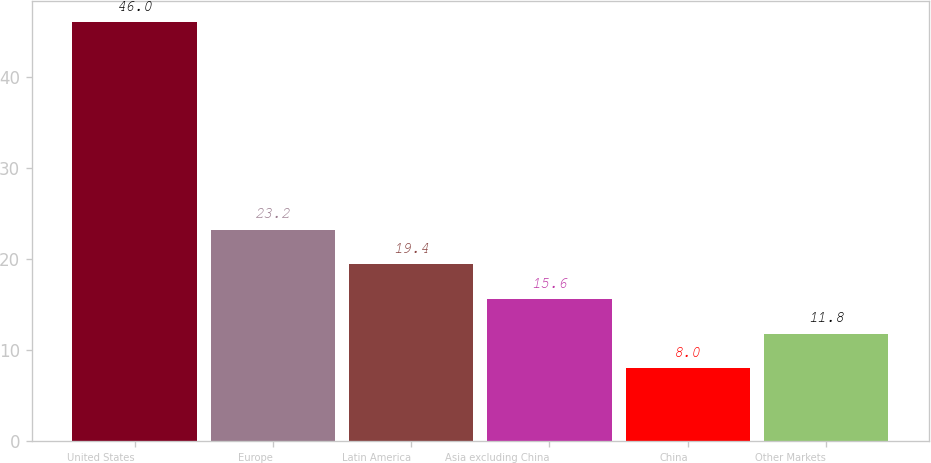Convert chart. <chart><loc_0><loc_0><loc_500><loc_500><bar_chart><fcel>United States<fcel>Europe<fcel>Latin America<fcel>Asia excluding China<fcel>China<fcel>Other Markets<nl><fcel>46<fcel>23.2<fcel>19.4<fcel>15.6<fcel>8<fcel>11.8<nl></chart> 